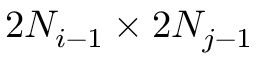<formula> <loc_0><loc_0><loc_500><loc_500>2 N _ { i - 1 } \times 2 N _ { j - 1 }</formula> 